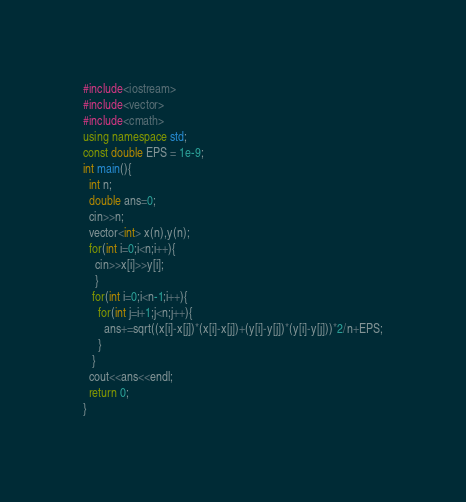<code> <loc_0><loc_0><loc_500><loc_500><_C++_>#include<iostream>
#include<vector>
#include<cmath>
using namespace std;
const double EPS = 1e-9;
int main(){
  int n;
  double ans=0;
  cin>>n;
  vector<int> x(n),y(n);
  for(int i=0;i<n;i++){
    cin>>x[i]>>y[i];
    }
   for(int i=0;i<n-1;i++){
     for(int j=i+1;j<n;j++){
       ans+=sqrt((x[i]-x[j])*(x[i]-x[j])+(y[i]-y[j])*(y[i]-y[j]))*2/n+EPS;
     }
   }
  cout<<ans<<endl;
  return 0;
}
</code> 